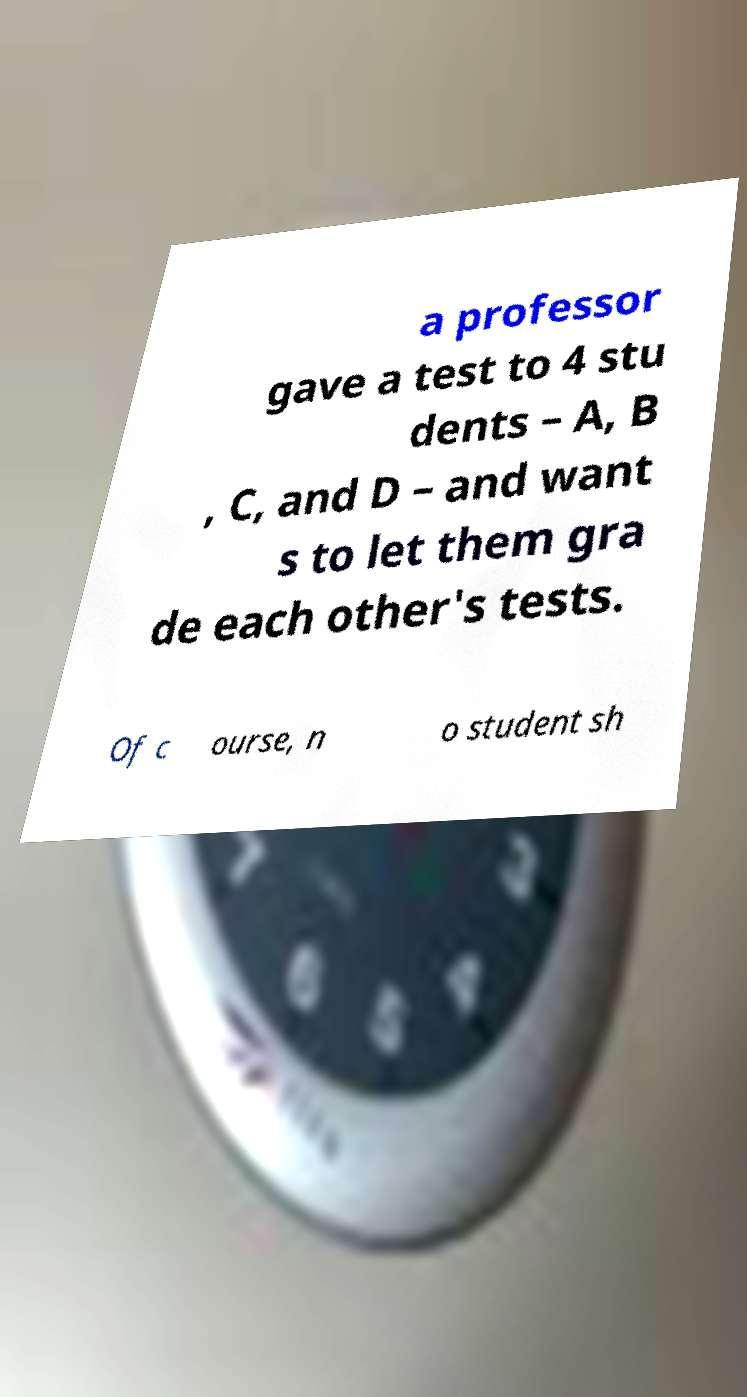Please identify and transcribe the text found in this image. a professor gave a test to 4 stu dents – A, B , C, and D – and want s to let them gra de each other's tests. Of c ourse, n o student sh 